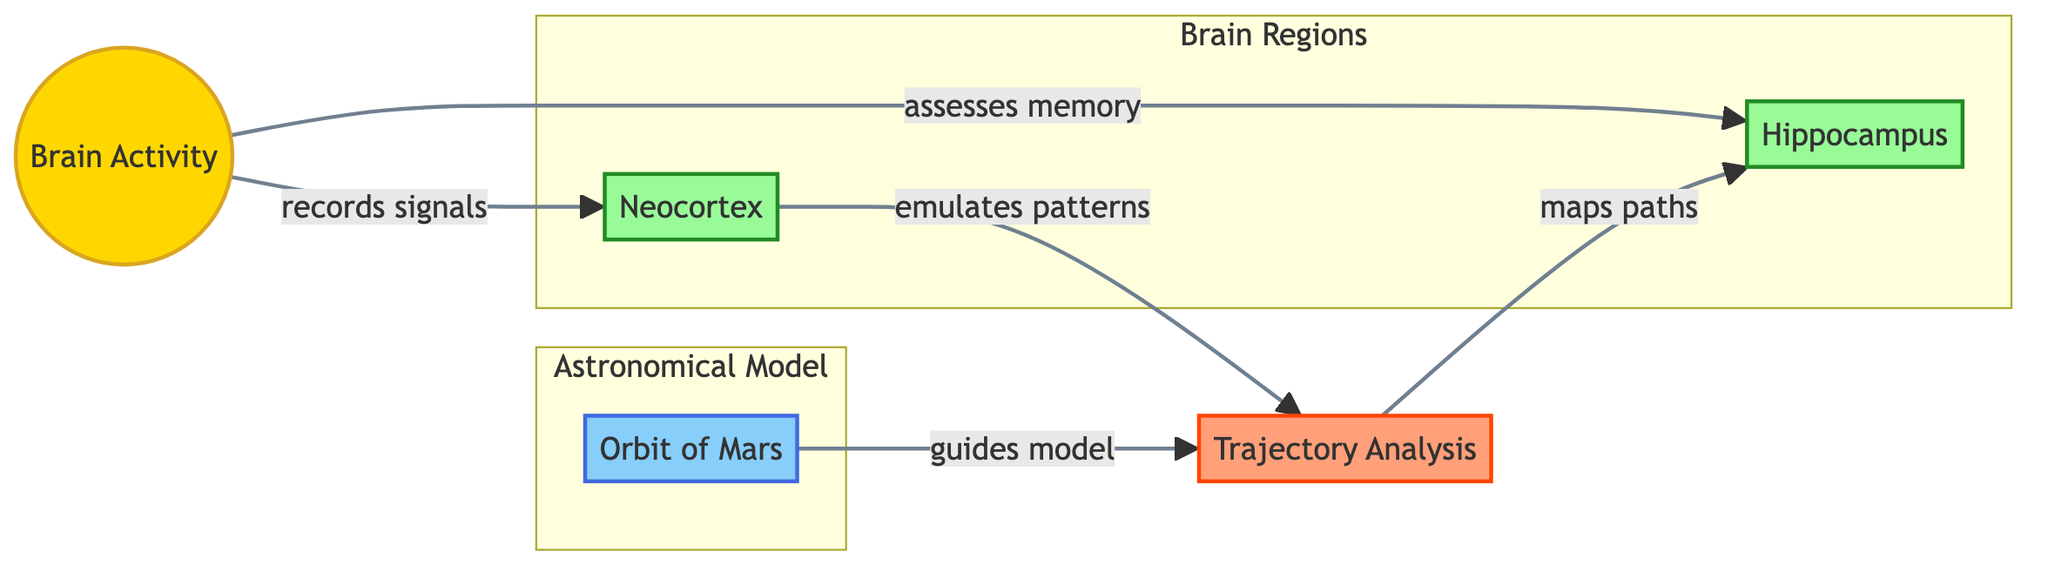What is the first node that Brain Activity records signals from? The diagram indicates that Brain Activity directly records signals from the Neocortex node. This relationship is shown with an arrow leading from Brain Activity to Neocortex.
Answer: Neocortex Which brain region is primarily associated with assessing memory? In the diagram, Brain Activity has a direct connection to the Hippocampus, indicating that this brain region analyzes memory as part of its function.
Answer: Hippocampus How many nodes are present in the diagram? By counting the nodes displayed in the diagram, we identify six different nodes: Orbit of Mars, Neocortex, Hippocampus, Brain Activity, Trajectory Analysis, and one additional node connecting them.
Answer: 6 What does the Trajectory Analysis node do in relation to the Hippocampus? The diagram shows that Trajectory Analysis maps paths to the Hippocampus, indicating a directional relationship where it contributes to understanding trajectories related to memory assessment in this brain region.
Answer: Maps paths Which model guides the Trajectory Analysis? From the diagram, it can be observed that Orbit of Mars guides the Trajectory Analysis, as indicated by the arrow connecting these two nodes.
Answer: Orbit of Mars How does the Neocortex contribute to Trajectory Analysis? The diagram illustrates that the Neocortex emulates patterns which are subsequently utilized by Trajectory Analysis. This means that the Neocortex plays a role in shaping the trajectory analysis process by providing relevant pattern information.
Answer: Emulates patterns Is the Brain Activity node classified as a concept, technique, region, or model? According to the diagram's class definitions, the Brain Activity node is classified under the concept category and is specifically highlighted in golden color representing its significance as a concept in this model.
Answer: Concept What type of analytical task does Trajectory Analysis perform? Trajectory Analysis in the diagram is identified as performing analysis related to trajectories, indicating that it focuses on studying the paths or movements in brain activity data as inspired by planetary motion.
Answer: Trajectory Analysis 